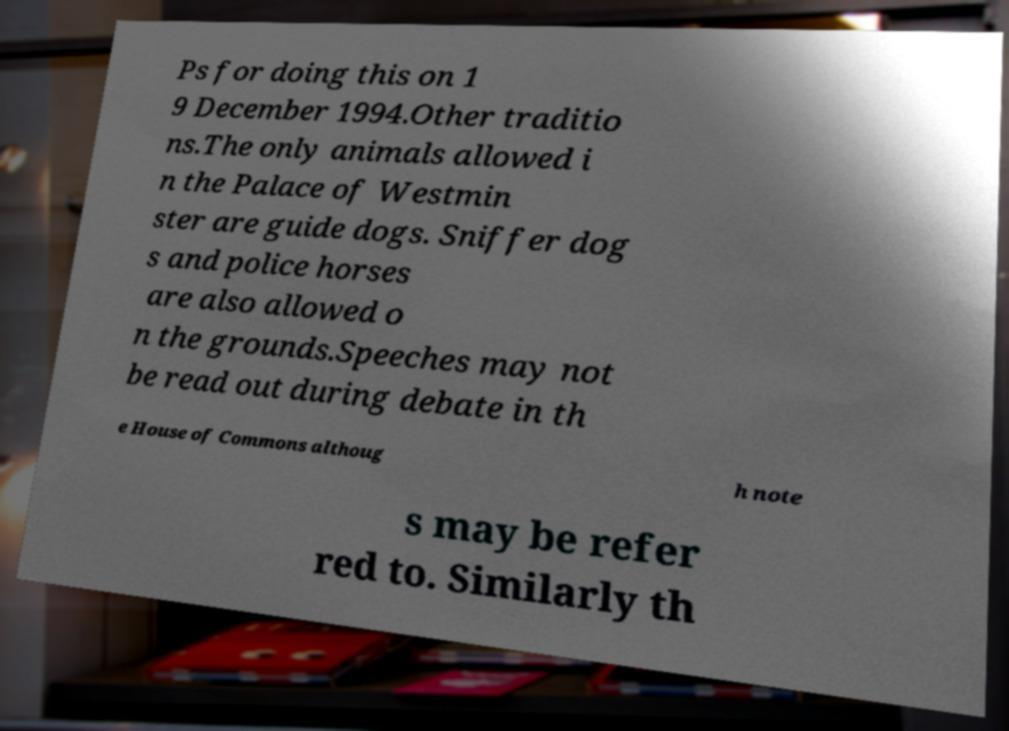Please identify and transcribe the text found in this image. Ps for doing this on 1 9 December 1994.Other traditio ns.The only animals allowed i n the Palace of Westmin ster are guide dogs. Sniffer dog s and police horses are also allowed o n the grounds.Speeches may not be read out during debate in th e House of Commons althoug h note s may be refer red to. Similarly th 